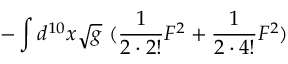<formula> <loc_0><loc_0><loc_500><loc_500>- \int d ^ { 1 0 } x \sqrt { g } ( \frac { 1 } { 2 \cdot 2 ! } F ^ { 2 } + \frac { 1 } { 2 \cdot 4 ! } F ^ { 2 } )</formula> 